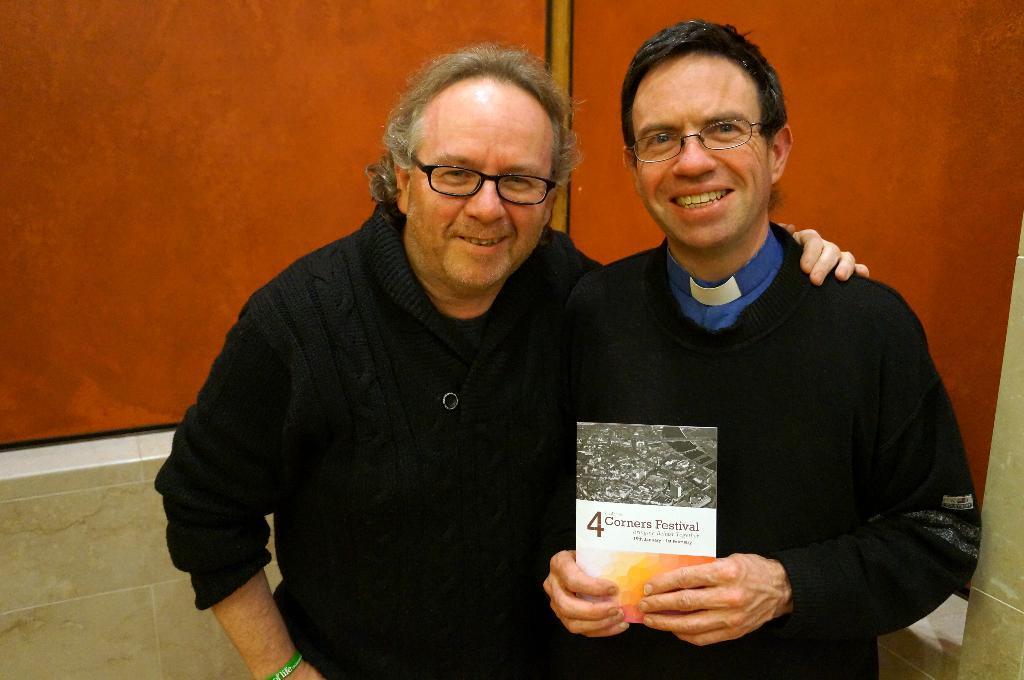Please provide a concise description of this image. In this image I can see two persons standing, the person at right is wearing blue and black color dress and holding the book and the person at left is wearing black color dress and the background is in brown and white color. 